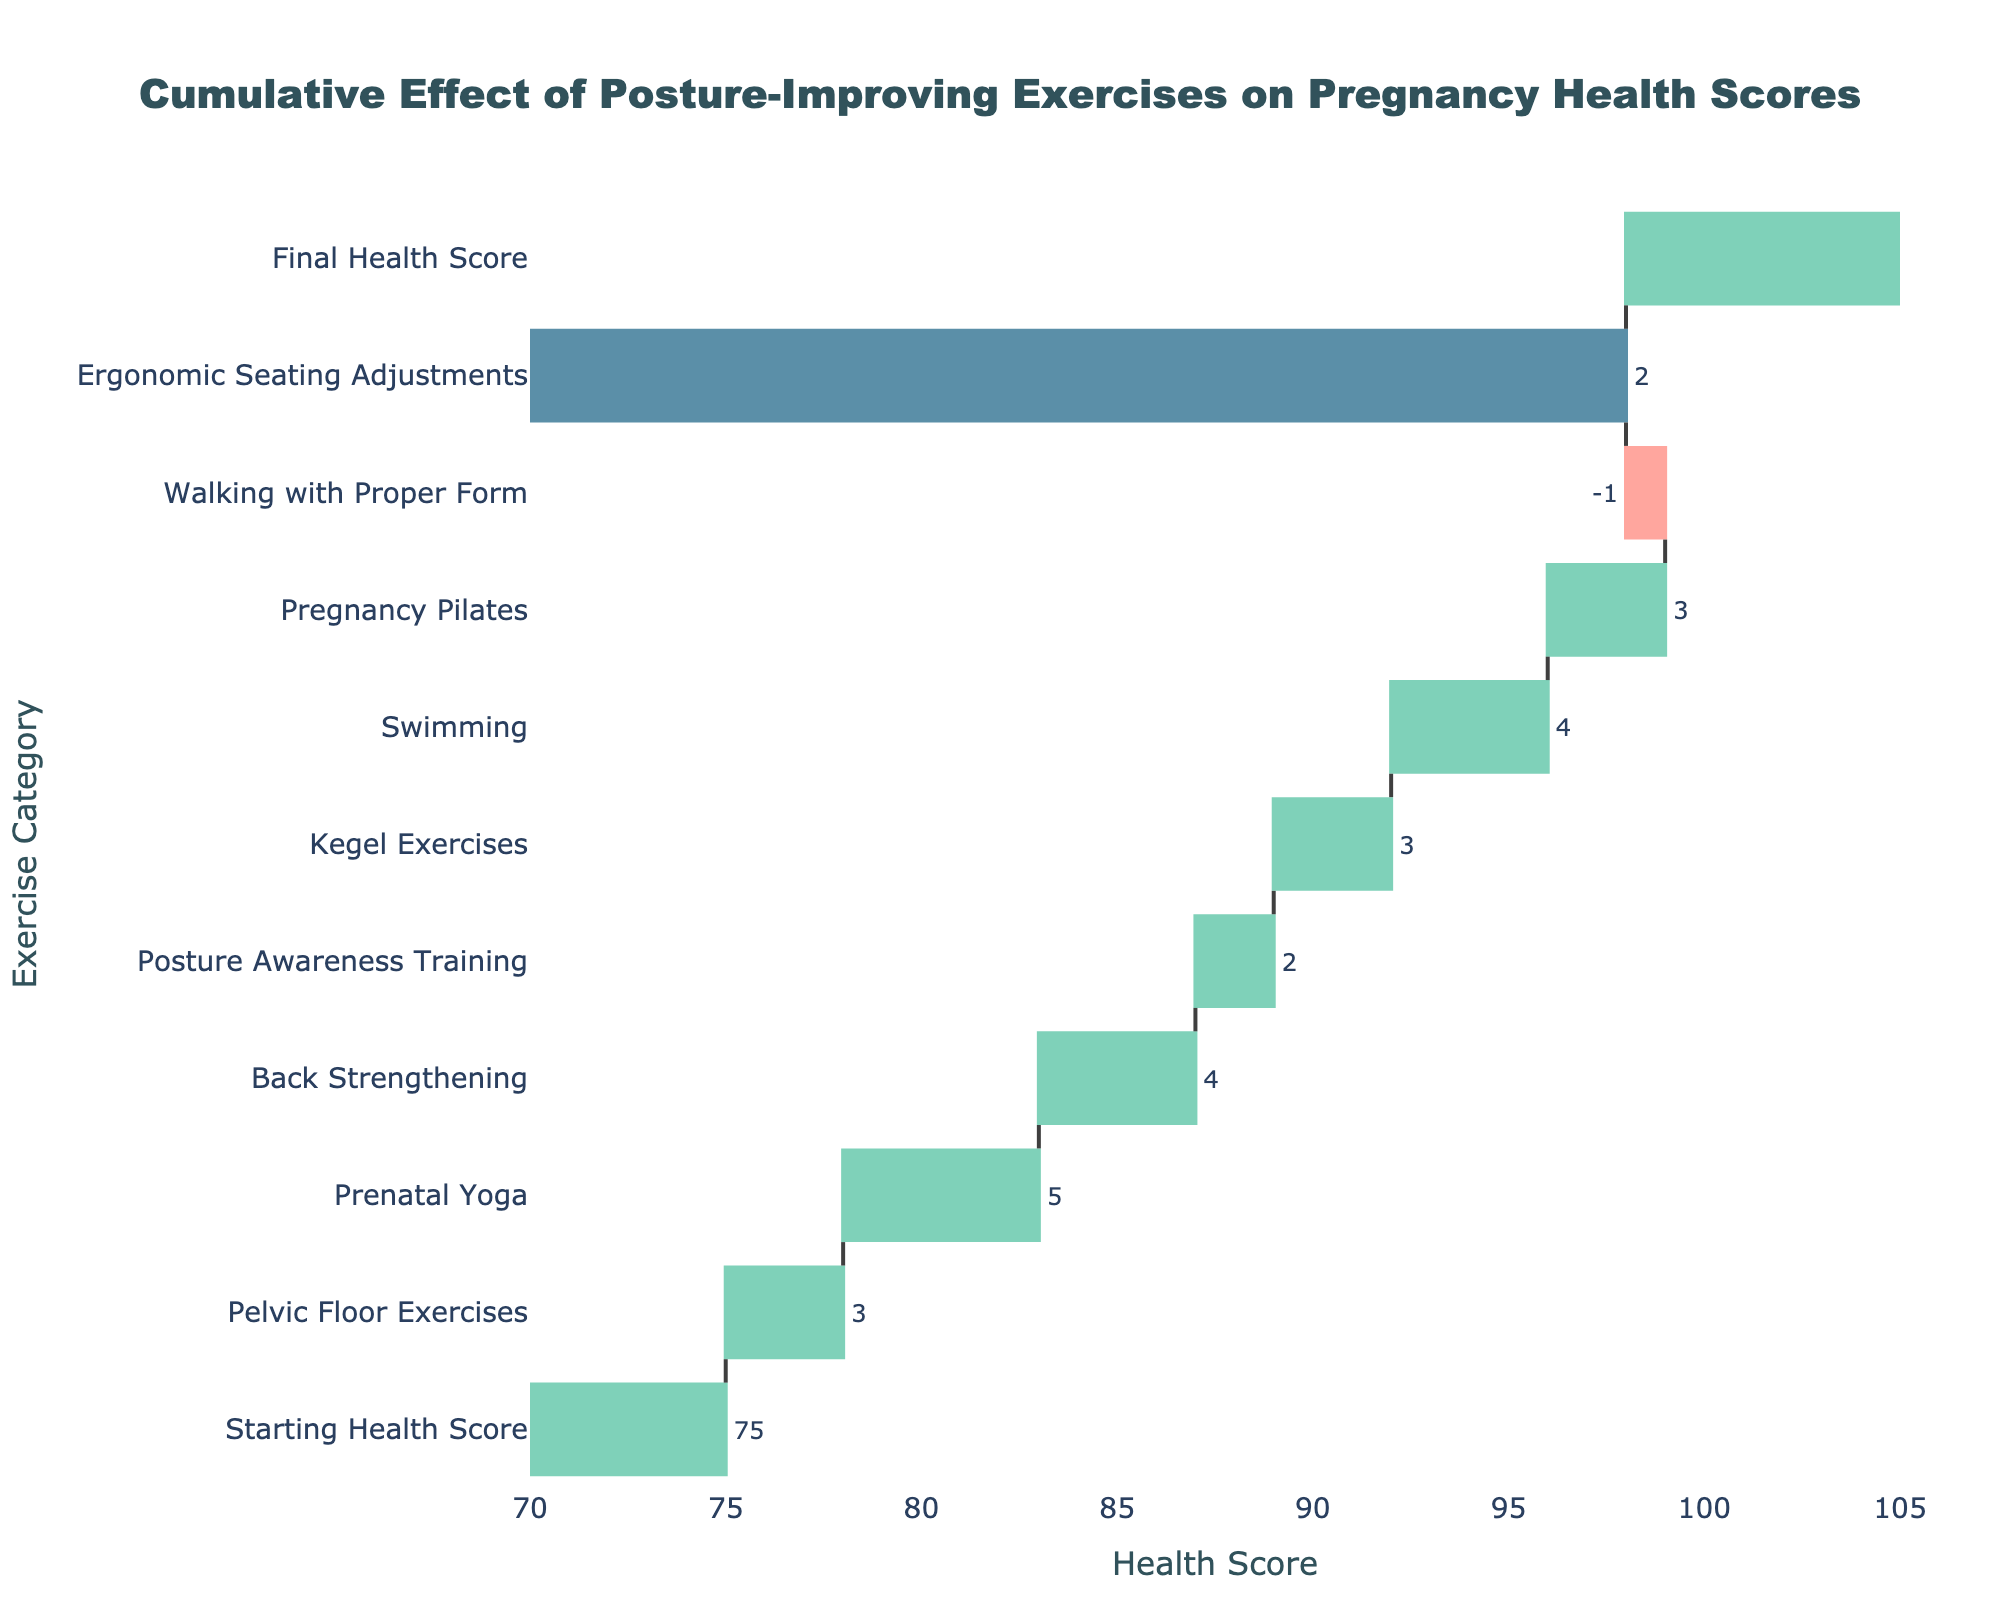What is the overall increase in the health score from all the exercises combined? The final health score is 100, starting from 75. The overall increase is calculated as 100 - 75 = 25.
Answer: 25 Which exercise contributed the most to the increase in the health score? By examining the values, Prenatal Yoga has the highest positive contribution of +5.
Answer: Prenatal Yoga How much did 'Walking with Proper Form' decrease the health score? According to the figure, 'Walking with Proper Form' decreases the health score by -1.
Answer: 1 What is the cumulative score after 'Back Strengthening'? Starting from 75, adding Pelvic Floor Exercises (+3) gives 78, then adding Prenatal Yoga (+5) gives 83, and finally, adding Back Strengthening (+4) gives a cumulative score of 87.
Answer: 87 Between 'Swimming' and 'Pregnancy Pilates,' which provided a higher increase in health score and by how much? Swimming increased the health score by +4, while Pregnancy Pilates increased it by +3. The difference is +4 - +3 = +1.
Answer: Swimming by 1 How does 'Pelvic Floor Exercises' compare to 'Kegel Exercises' in terms of health score improvement? Both exercises contribute equally to the health score, each increasing it by +3.
Answer: Equal What is the total contribution to the health score from 'Posture Awareness Training' and 'Ergonomic Seating Adjustments'? The total is the sum of the contributions: Posture Awareness Training (+2) and Ergonomic Seating Adjustments (+2). So, 2 + 2 = 4.
Answer: 4 Which exercise has the least impact on the health score, and what is that impact? 'Posture Awareness Training' has the least positive impact with an increase of +2.
Answer: Posture Awareness Training, +2 If the starting health score was 80, what would be the final health score after accounting for all the exercises? Starting from 80 and applying the total increase of +25 (from the figure), the final score would be 80 + 25 = 105.
Answer: 105 What is the average increase in health score per exercise (excluding the starting and final scores)? The exercises have the following contributions: +3, +5, +4, +2, +3, +4, +3, -1, +2. The sum is 25, and there are 9 exercises. So, the average is 25 / 9 ≈ 2.78.
Answer: 2.78 